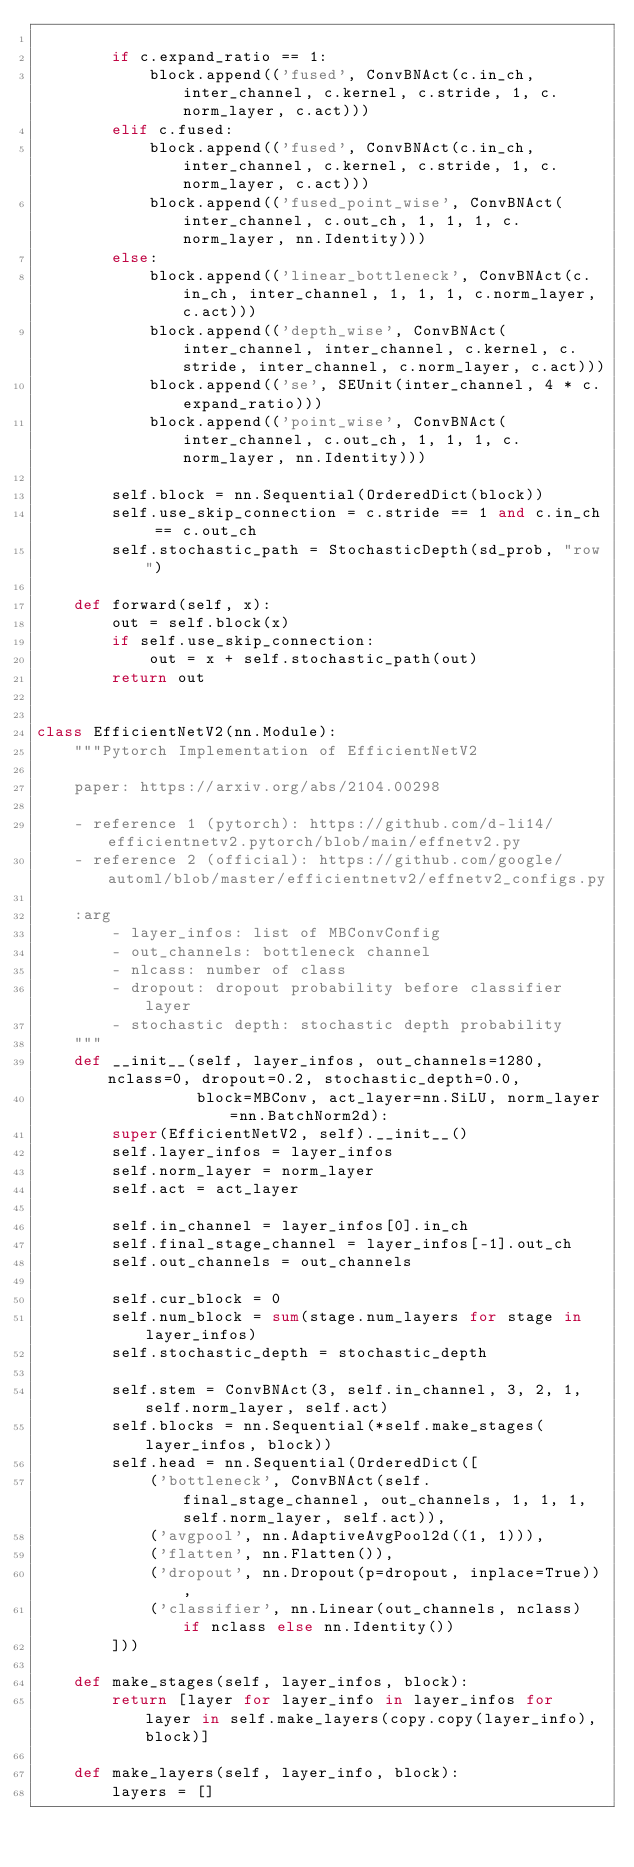<code> <loc_0><loc_0><loc_500><loc_500><_Python_>
        if c.expand_ratio == 1:
            block.append(('fused', ConvBNAct(c.in_ch, inter_channel, c.kernel, c.stride, 1, c.norm_layer, c.act)))
        elif c.fused:
            block.append(('fused', ConvBNAct(c.in_ch, inter_channel, c.kernel, c.stride, 1, c.norm_layer, c.act)))
            block.append(('fused_point_wise', ConvBNAct(inter_channel, c.out_ch, 1, 1, 1, c.norm_layer, nn.Identity)))
        else:
            block.append(('linear_bottleneck', ConvBNAct(c.in_ch, inter_channel, 1, 1, 1, c.norm_layer, c.act)))
            block.append(('depth_wise', ConvBNAct(inter_channel, inter_channel, c.kernel, c.stride, inter_channel, c.norm_layer, c.act)))
            block.append(('se', SEUnit(inter_channel, 4 * c.expand_ratio)))
            block.append(('point_wise', ConvBNAct(inter_channel, c.out_ch, 1, 1, 1, c.norm_layer, nn.Identity)))

        self.block = nn.Sequential(OrderedDict(block))
        self.use_skip_connection = c.stride == 1 and c.in_ch == c.out_ch
        self.stochastic_path = StochasticDepth(sd_prob, "row")

    def forward(self, x):
        out = self.block(x)
        if self.use_skip_connection:
            out = x + self.stochastic_path(out)
        return out


class EfficientNetV2(nn.Module):
    """Pytorch Implementation of EfficientNetV2

    paper: https://arxiv.org/abs/2104.00298

    - reference 1 (pytorch): https://github.com/d-li14/efficientnetv2.pytorch/blob/main/effnetv2.py
    - reference 2 (official): https://github.com/google/automl/blob/master/efficientnetv2/effnetv2_configs.py

    :arg
        - layer_infos: list of MBConvConfig
        - out_channels: bottleneck channel
        - nlcass: number of class
        - dropout: dropout probability before classifier layer
        - stochastic depth: stochastic depth probability
    """
    def __init__(self, layer_infos, out_channels=1280, nclass=0, dropout=0.2, stochastic_depth=0.0,
                 block=MBConv, act_layer=nn.SiLU, norm_layer=nn.BatchNorm2d):
        super(EfficientNetV2, self).__init__()
        self.layer_infos = layer_infos
        self.norm_layer = norm_layer
        self.act = act_layer

        self.in_channel = layer_infos[0].in_ch
        self.final_stage_channel = layer_infos[-1].out_ch
        self.out_channels = out_channels

        self.cur_block = 0
        self.num_block = sum(stage.num_layers for stage in layer_infos)
        self.stochastic_depth = stochastic_depth

        self.stem = ConvBNAct(3, self.in_channel, 3, 2, 1, self.norm_layer, self.act)
        self.blocks = nn.Sequential(*self.make_stages(layer_infos, block))
        self.head = nn.Sequential(OrderedDict([
            ('bottleneck', ConvBNAct(self.final_stage_channel, out_channels, 1, 1, 1, self.norm_layer, self.act)),
            ('avgpool', nn.AdaptiveAvgPool2d((1, 1))),
            ('flatten', nn.Flatten()),
            ('dropout', nn.Dropout(p=dropout, inplace=True)),
            ('classifier', nn.Linear(out_channels, nclass) if nclass else nn.Identity())
        ]))

    def make_stages(self, layer_infos, block):
        return [layer for layer_info in layer_infos for layer in self.make_layers(copy.copy(layer_info), block)]

    def make_layers(self, layer_info, block):
        layers = []</code> 